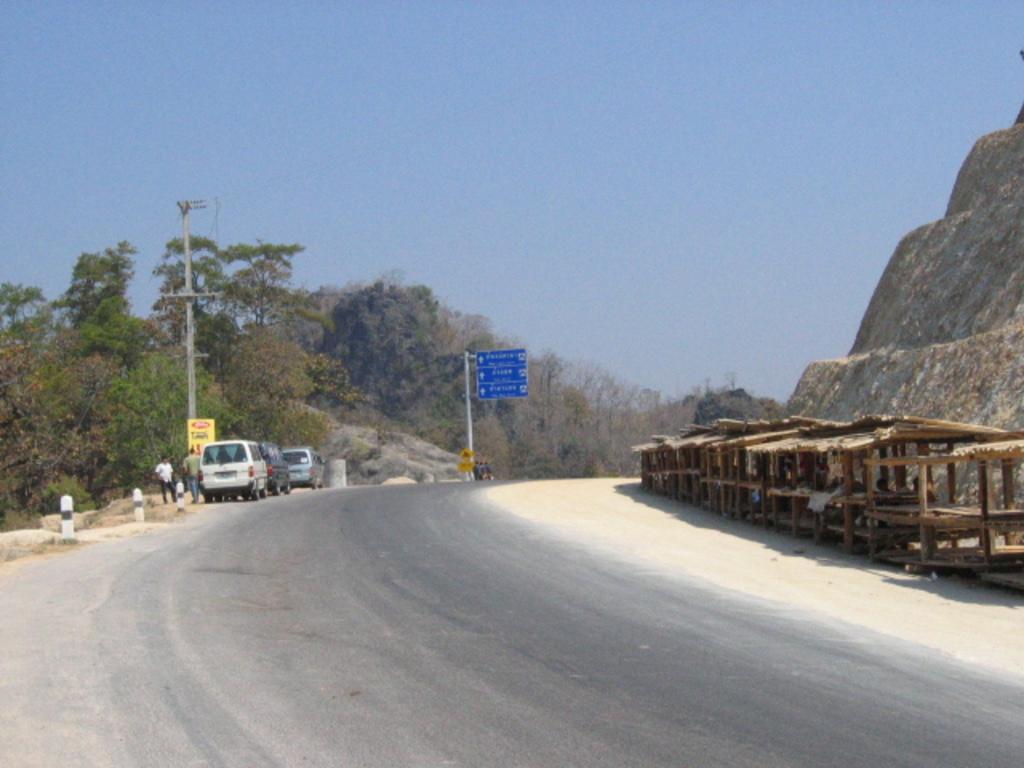Describe this image in one or two sentences. In this image we can see a road, vehicles, poles, boards, trees, mountain, people, and few objects. In the background there is sky. 